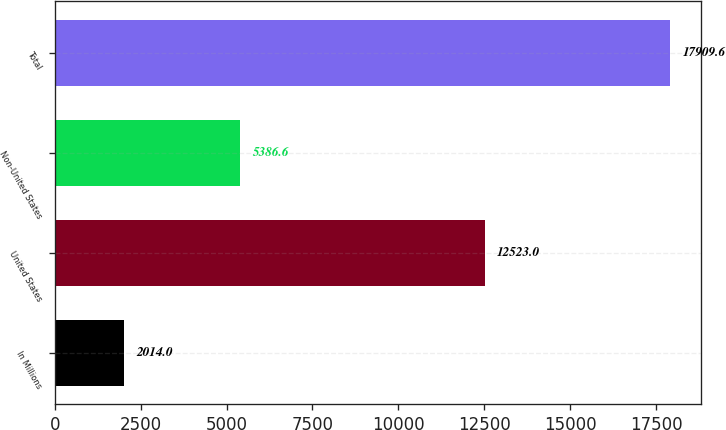Convert chart. <chart><loc_0><loc_0><loc_500><loc_500><bar_chart><fcel>In Millions<fcel>United States<fcel>Non-United States<fcel>Total<nl><fcel>2014<fcel>12523<fcel>5386.6<fcel>17909.6<nl></chart> 